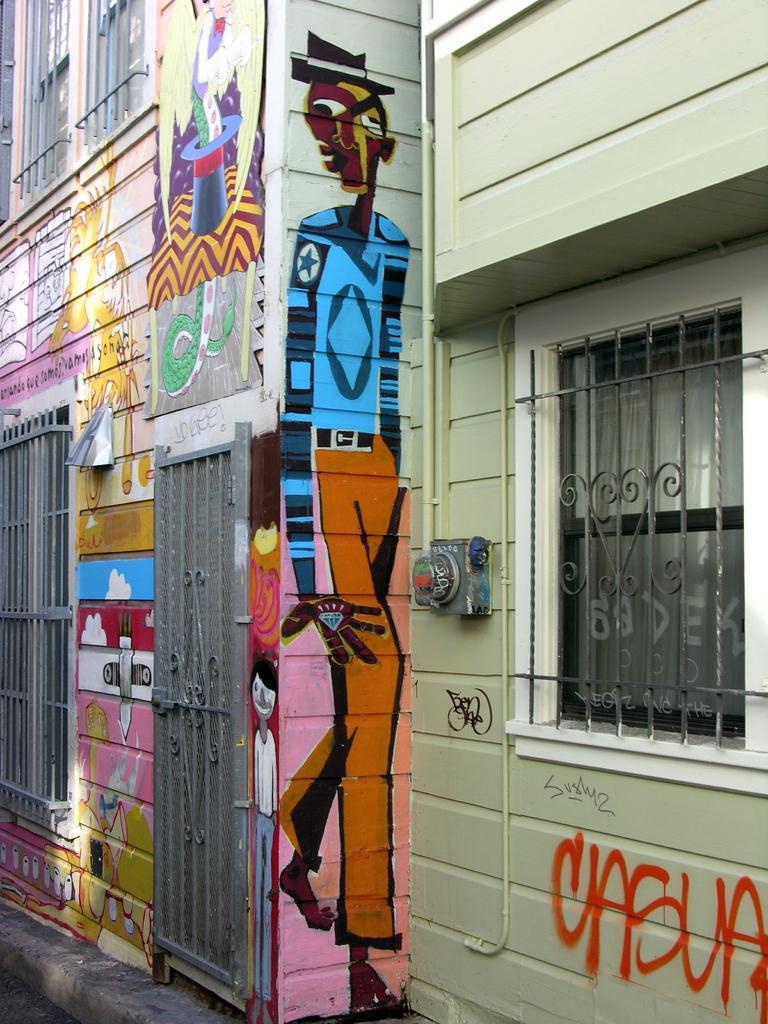Describe this image in one or two sentences. The picture is taken outside a street. In this picture, the walls are painted with different images. On the right there is a window. On the left there is a window and gate. 